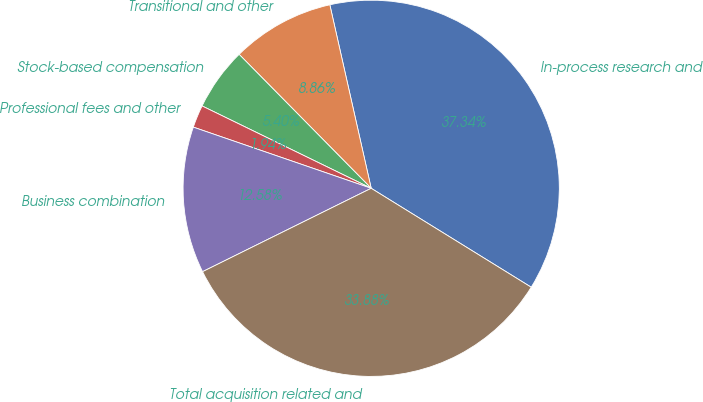Convert chart. <chart><loc_0><loc_0><loc_500><loc_500><pie_chart><fcel>In-process research and<fcel>Transitional and other<fcel>Stock-based compensation<fcel>Professional fees and other<fcel>Business combination<fcel>Total acquisition related and<nl><fcel>37.34%<fcel>8.86%<fcel>5.4%<fcel>1.94%<fcel>12.58%<fcel>33.88%<nl></chart> 